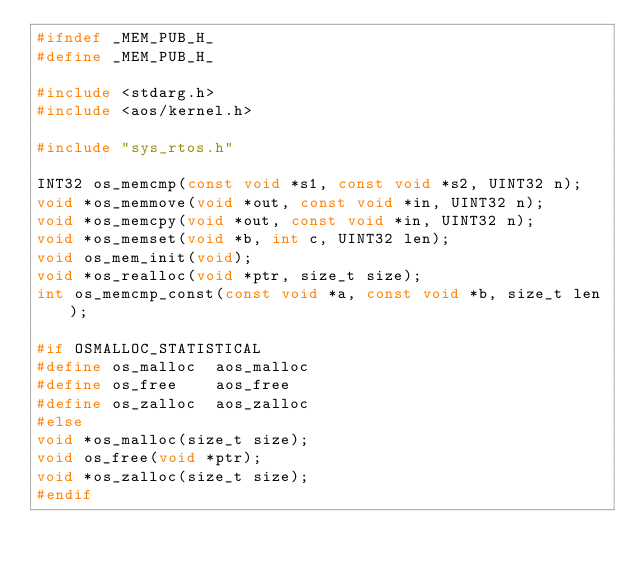Convert code to text. <code><loc_0><loc_0><loc_500><loc_500><_C_>#ifndef _MEM_PUB_H_
#define _MEM_PUB_H_

#include <stdarg.h>
#include <aos/kernel.h>

#include "sys_rtos.h"

INT32 os_memcmp(const void *s1, const void *s2, UINT32 n);
void *os_memmove(void *out, const void *in, UINT32 n);
void *os_memcpy(void *out, const void *in, UINT32 n);
void *os_memset(void *b, int c, UINT32 len);
void os_mem_init(void);
void *os_realloc(void *ptr, size_t size);
int os_memcmp_const(const void *a, const void *b, size_t len);

#if OSMALLOC_STATISTICAL
#define os_malloc  aos_malloc
#define os_free    aos_free
#define os_zalloc  aos_zalloc
#else
void *os_malloc(size_t size);
void os_free(void *ptr);
void *os_zalloc(size_t size);
#endif
</code> 